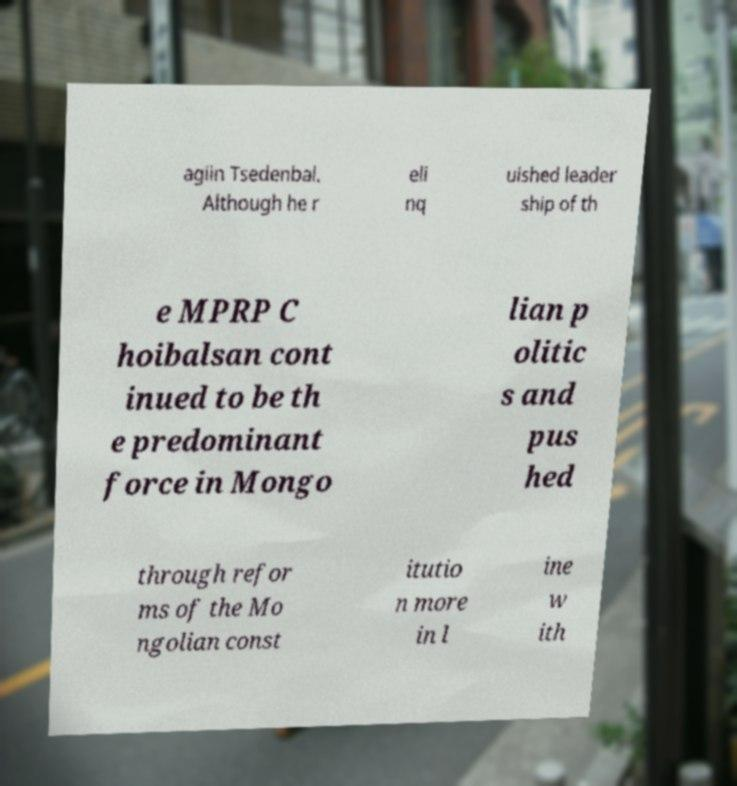Can you read and provide the text displayed in the image?This photo seems to have some interesting text. Can you extract and type it out for me? agiin Tsedenbal. Although he r eli nq uished leader ship of th e MPRP C hoibalsan cont inued to be th e predominant force in Mongo lian p olitic s and pus hed through refor ms of the Mo ngolian const itutio n more in l ine w ith 